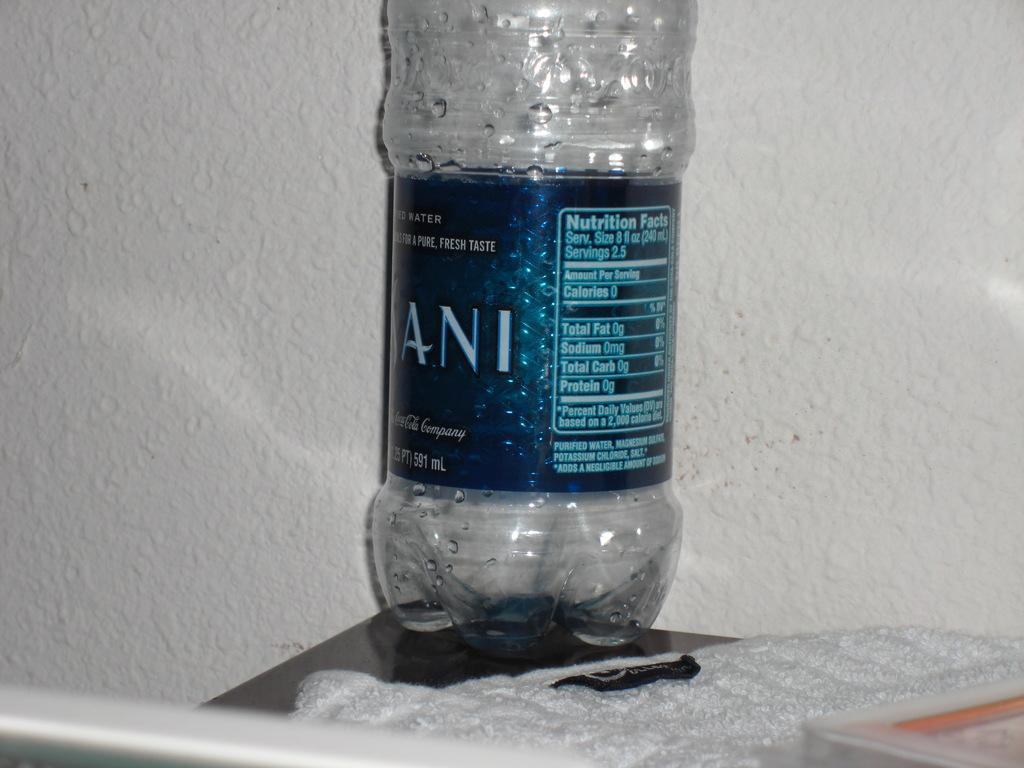What is the serving size of this bottle?
Offer a terse response. 591 ml. 